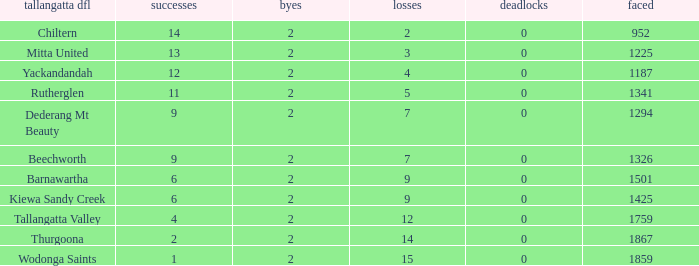What is the most byes with 11 wins and fewer than 1867 againsts? 2.0. 